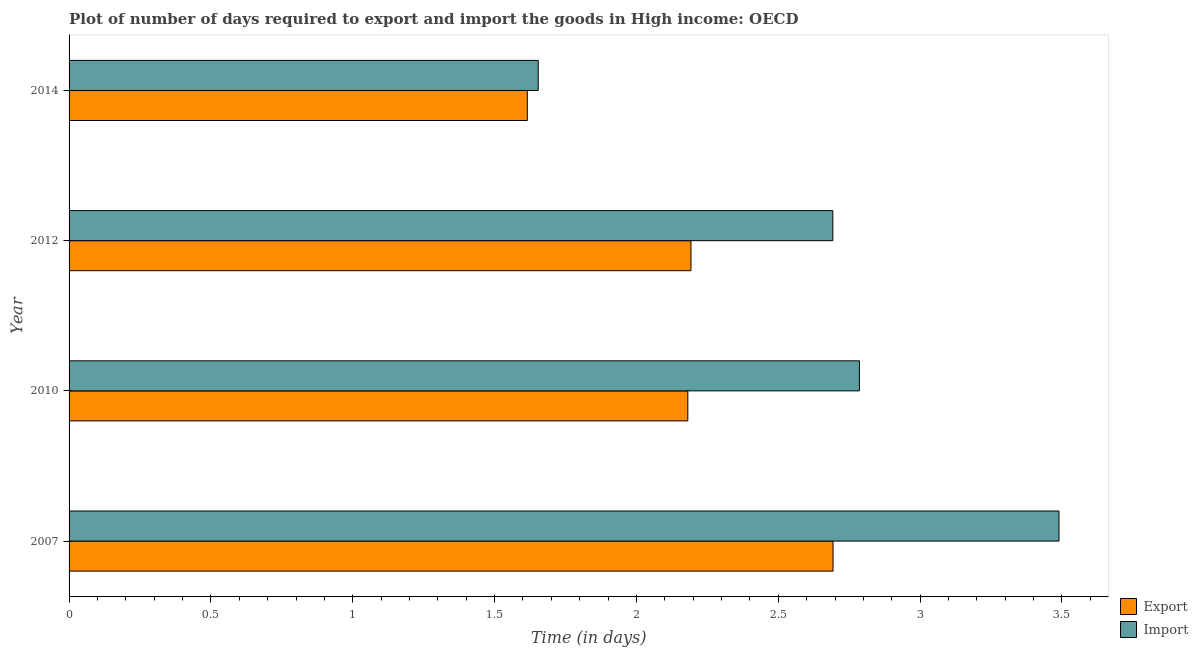How many different coloured bars are there?
Ensure brevity in your answer.  2. How many groups of bars are there?
Provide a short and direct response. 4. How many bars are there on the 2nd tick from the top?
Ensure brevity in your answer.  2. How many bars are there on the 1st tick from the bottom?
Offer a terse response. 2. In how many cases, is the number of bars for a given year not equal to the number of legend labels?
Provide a succinct answer. 0. What is the time required to import in 2014?
Give a very brief answer. 1.65. Across all years, what is the maximum time required to export?
Offer a very short reply. 2.69. Across all years, what is the minimum time required to import?
Your answer should be compact. 1.65. What is the total time required to import in the graph?
Provide a short and direct response. 10.62. What is the difference between the time required to export in 2007 and that in 2014?
Keep it short and to the point. 1.08. What is the difference between the time required to import in 2007 and the time required to export in 2014?
Ensure brevity in your answer.  1.87. What is the average time required to import per year?
Your answer should be compact. 2.65. What is the ratio of the time required to export in 2007 to that in 2010?
Ensure brevity in your answer.  1.24. Is the time required to export in 2010 less than that in 2012?
Offer a terse response. Yes. Is the difference between the time required to import in 2007 and 2014 greater than the difference between the time required to export in 2007 and 2014?
Your answer should be compact. Yes. What is the difference between the highest and the second highest time required to export?
Give a very brief answer. 0.5. What is the difference between the highest and the lowest time required to export?
Offer a terse response. 1.08. What does the 2nd bar from the top in 2010 represents?
Your answer should be very brief. Export. What does the 1st bar from the bottom in 2014 represents?
Offer a very short reply. Export. How many bars are there?
Your answer should be very brief. 8. Are all the bars in the graph horizontal?
Keep it short and to the point. Yes. How many years are there in the graph?
Give a very brief answer. 4. What is the difference between two consecutive major ticks on the X-axis?
Keep it short and to the point. 0.5. Does the graph contain grids?
Your answer should be compact. No. Where does the legend appear in the graph?
Make the answer very short. Bottom right. How are the legend labels stacked?
Provide a short and direct response. Vertical. What is the title of the graph?
Ensure brevity in your answer.  Plot of number of days required to export and import the goods in High income: OECD. What is the label or title of the X-axis?
Provide a short and direct response. Time (in days). What is the label or title of the Y-axis?
Offer a very short reply. Year. What is the Time (in days) in Export in 2007?
Offer a terse response. 2.69. What is the Time (in days) in Import in 2007?
Provide a short and direct response. 3.49. What is the Time (in days) in Export in 2010?
Offer a terse response. 2.18. What is the Time (in days) in Import in 2010?
Provide a short and direct response. 2.79. What is the Time (in days) in Export in 2012?
Ensure brevity in your answer.  2.19. What is the Time (in days) of Import in 2012?
Provide a short and direct response. 2.69. What is the Time (in days) in Export in 2014?
Ensure brevity in your answer.  1.62. What is the Time (in days) of Import in 2014?
Your response must be concise. 1.65. Across all years, what is the maximum Time (in days) in Export?
Your answer should be very brief. 2.69. Across all years, what is the maximum Time (in days) in Import?
Your response must be concise. 3.49. Across all years, what is the minimum Time (in days) in Export?
Provide a short and direct response. 1.62. Across all years, what is the minimum Time (in days) of Import?
Offer a very short reply. 1.65. What is the total Time (in days) in Export in the graph?
Offer a very short reply. 8.68. What is the total Time (in days) of Import in the graph?
Provide a short and direct response. 10.62. What is the difference between the Time (in days) of Export in 2007 and that in 2010?
Your response must be concise. 0.51. What is the difference between the Time (in days) of Import in 2007 and that in 2010?
Make the answer very short. 0.7. What is the difference between the Time (in days) in Export in 2007 and that in 2012?
Offer a very short reply. 0.5. What is the difference between the Time (in days) of Import in 2007 and that in 2012?
Keep it short and to the point. 0.8. What is the difference between the Time (in days) in Export in 2007 and that in 2014?
Provide a succinct answer. 1.08. What is the difference between the Time (in days) of Import in 2007 and that in 2014?
Your answer should be very brief. 1.84. What is the difference between the Time (in days) of Export in 2010 and that in 2012?
Offer a very short reply. -0.01. What is the difference between the Time (in days) in Import in 2010 and that in 2012?
Give a very brief answer. 0.09. What is the difference between the Time (in days) in Export in 2010 and that in 2014?
Give a very brief answer. 0.57. What is the difference between the Time (in days) in Import in 2010 and that in 2014?
Keep it short and to the point. 1.13. What is the difference between the Time (in days) in Export in 2012 and that in 2014?
Provide a succinct answer. 0.58. What is the difference between the Time (in days) of Import in 2012 and that in 2014?
Make the answer very short. 1.04. What is the difference between the Time (in days) of Export in 2007 and the Time (in days) of Import in 2010?
Keep it short and to the point. -0.09. What is the difference between the Time (in days) of Export in 2007 and the Time (in days) of Import in 2012?
Ensure brevity in your answer.  0. What is the difference between the Time (in days) of Export in 2007 and the Time (in days) of Import in 2014?
Provide a succinct answer. 1.04. What is the difference between the Time (in days) in Export in 2010 and the Time (in days) in Import in 2012?
Keep it short and to the point. -0.51. What is the difference between the Time (in days) of Export in 2010 and the Time (in days) of Import in 2014?
Keep it short and to the point. 0.53. What is the difference between the Time (in days) in Export in 2012 and the Time (in days) in Import in 2014?
Provide a short and direct response. 0.54. What is the average Time (in days) in Export per year?
Offer a terse response. 2.17. What is the average Time (in days) of Import per year?
Offer a very short reply. 2.66. In the year 2007, what is the difference between the Time (in days) in Export and Time (in days) in Import?
Keep it short and to the point. -0.8. In the year 2010, what is the difference between the Time (in days) in Export and Time (in days) in Import?
Provide a short and direct response. -0.6. In the year 2014, what is the difference between the Time (in days) in Export and Time (in days) in Import?
Make the answer very short. -0.04. What is the ratio of the Time (in days) in Export in 2007 to that in 2010?
Provide a short and direct response. 1.23. What is the ratio of the Time (in days) in Import in 2007 to that in 2010?
Offer a terse response. 1.25. What is the ratio of the Time (in days) of Export in 2007 to that in 2012?
Provide a succinct answer. 1.23. What is the ratio of the Time (in days) of Import in 2007 to that in 2012?
Your response must be concise. 1.3. What is the ratio of the Time (in days) of Export in 2007 to that in 2014?
Your answer should be compact. 1.67. What is the ratio of the Time (in days) of Import in 2007 to that in 2014?
Your answer should be very brief. 2.11. What is the ratio of the Time (in days) in Import in 2010 to that in 2012?
Offer a terse response. 1.03. What is the ratio of the Time (in days) of Export in 2010 to that in 2014?
Give a very brief answer. 1.35. What is the ratio of the Time (in days) of Import in 2010 to that in 2014?
Provide a short and direct response. 1.68. What is the ratio of the Time (in days) of Export in 2012 to that in 2014?
Offer a terse response. 1.36. What is the ratio of the Time (in days) in Import in 2012 to that in 2014?
Offer a terse response. 1.63. What is the difference between the highest and the second highest Time (in days) in Export?
Provide a succinct answer. 0.5. What is the difference between the highest and the second highest Time (in days) in Import?
Keep it short and to the point. 0.7. What is the difference between the highest and the lowest Time (in days) in Export?
Keep it short and to the point. 1.08. What is the difference between the highest and the lowest Time (in days) of Import?
Your answer should be compact. 1.84. 